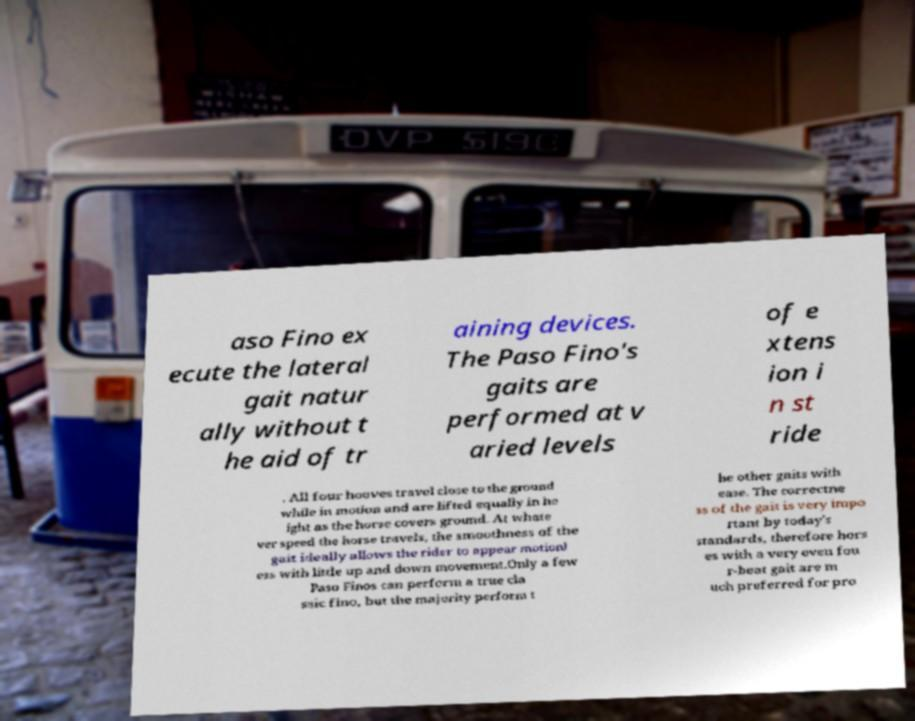I need the written content from this picture converted into text. Can you do that? aso Fino ex ecute the lateral gait natur ally without t he aid of tr aining devices. The Paso Fino's gaits are performed at v aried levels of e xtens ion i n st ride . All four hooves travel close to the ground while in motion and are lifted equally in he ight as the horse covers ground. At whate ver speed the horse travels, the smoothness of the gait ideally allows the rider to appear motionl ess with little up and down movement.Only a few Paso Finos can perform a true cla ssic fino, but the majority perform t he other gaits with ease. The correctne ss of the gait is very impo rtant by today's standards, therefore hors es with a very even fou r-beat gait are m uch preferred for pro 